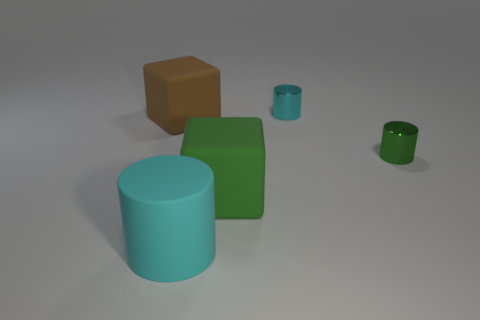The thing that is behind the green cylinder and left of the small cyan metal cylinder has what shape?
Provide a succinct answer. Cube. What shape is the small object that is in front of the big brown object?
Offer a terse response. Cylinder. What is the size of the cyan cylinder behind the metallic thing that is on the right side of the tiny cylinder behind the large brown matte thing?
Offer a terse response. Small. Do the cyan metal object and the cyan rubber thing have the same shape?
Offer a terse response. Yes. There is a thing that is in front of the green cylinder and right of the large cyan rubber cylinder; what is its size?
Your answer should be compact. Large. What material is the big green object that is the same shape as the big brown object?
Offer a very short reply. Rubber. There is a cyan thing that is in front of the metal cylinder in front of the tiny cyan cylinder; what is it made of?
Keep it short and to the point. Rubber. There is a big cyan object; does it have the same shape as the cyan object that is right of the big cylinder?
Your answer should be compact. Yes. How many rubber things are either yellow objects or blocks?
Provide a short and direct response. 2. What color is the small object that is behind the tiny shiny cylinder that is in front of the cyan object that is right of the big cyan matte object?
Make the answer very short. Cyan. 